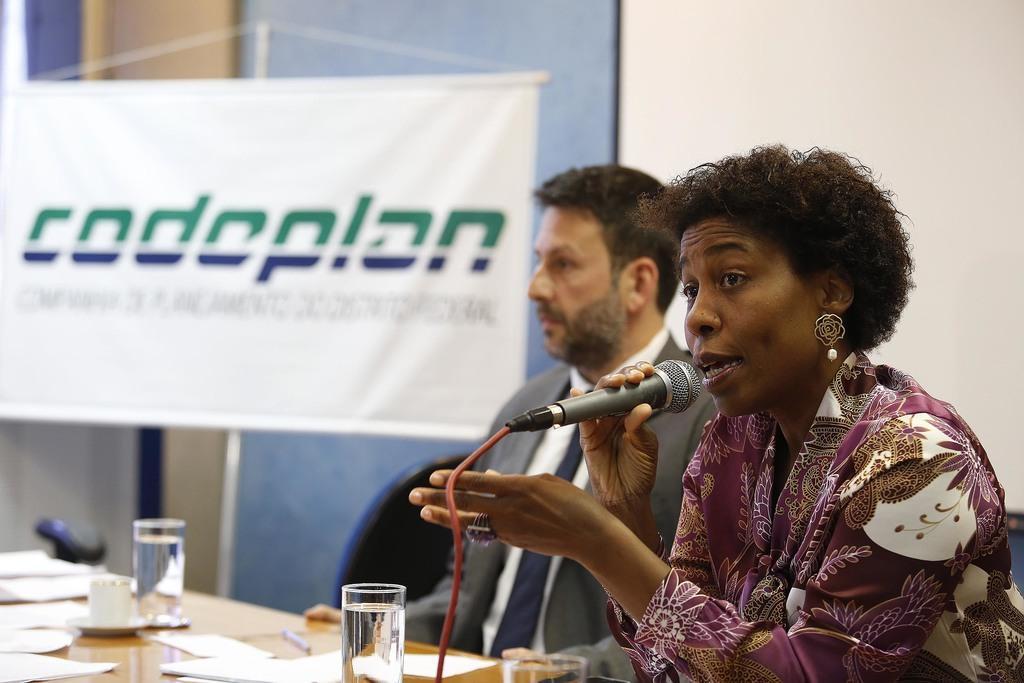Could you give a brief overview of what you see in this image? In this image I can see a man and a woman are sitting on chairs, here I can see she is holding a mic. On this table I can see I can see few papers, few glass and a cup. 